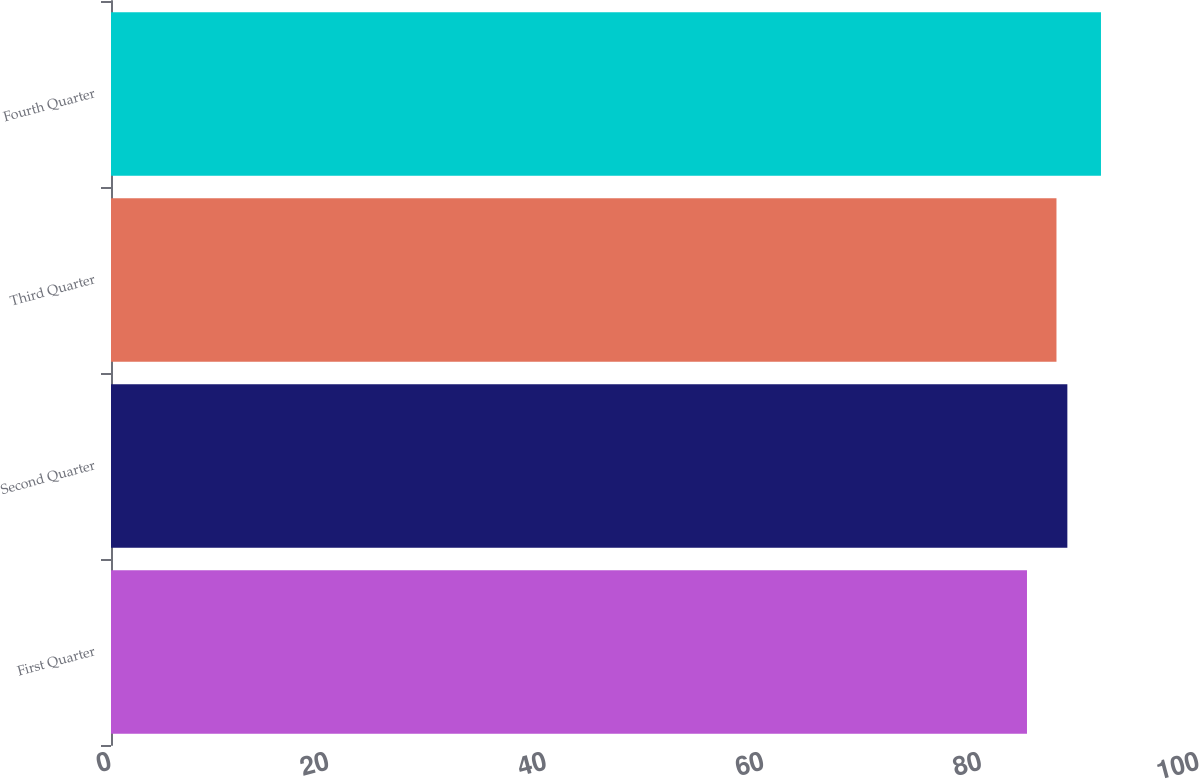Convert chart. <chart><loc_0><loc_0><loc_500><loc_500><bar_chart><fcel>First Quarter<fcel>Second Quarter<fcel>Third Quarter<fcel>Fourth Quarter<nl><fcel>84.19<fcel>87.9<fcel>86.9<fcel>90.99<nl></chart> 